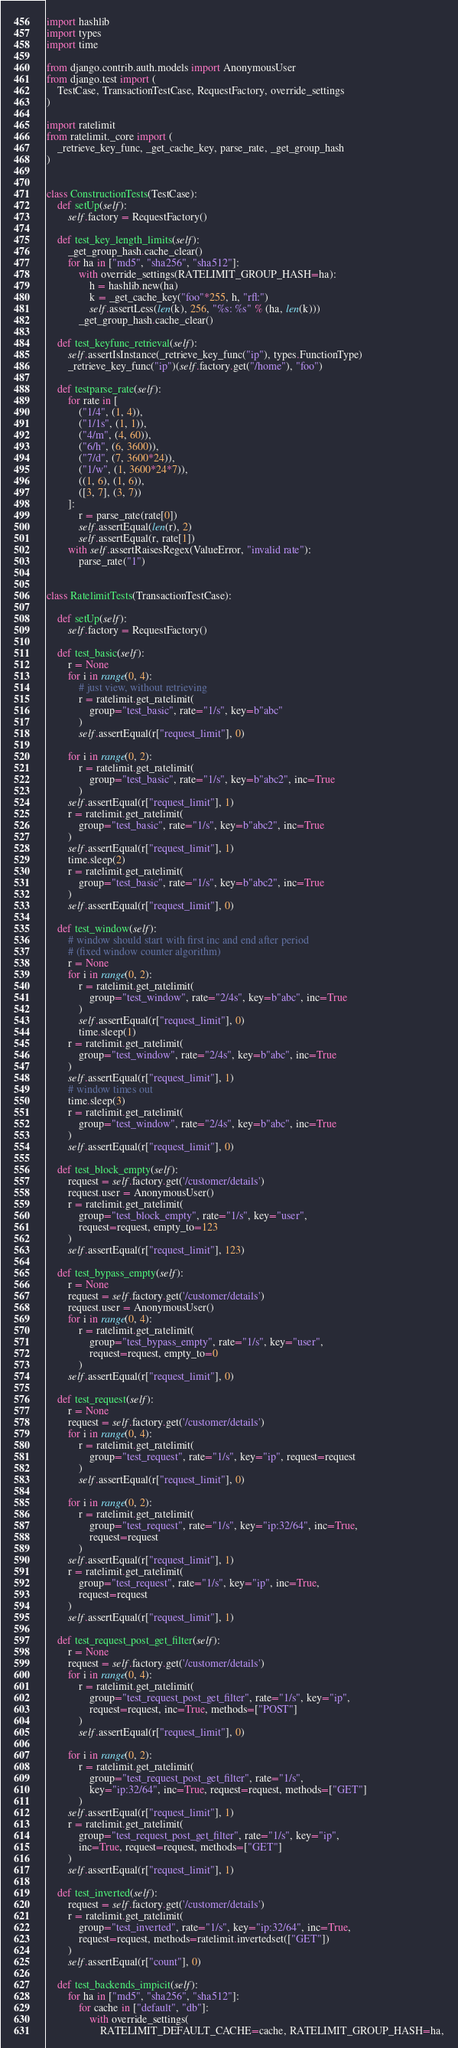Convert code to text. <code><loc_0><loc_0><loc_500><loc_500><_Python_>
import hashlib
import types
import time

from django.contrib.auth.models import AnonymousUser
from django.test import (
    TestCase, TransactionTestCase, RequestFactory, override_settings
)

import ratelimit
from ratelimit._core import (
    _retrieve_key_func, _get_cache_key, parse_rate, _get_group_hash
)


class ConstructionTests(TestCase):
    def setUp(self):
        self.factory = RequestFactory()

    def test_key_length_limits(self):
        _get_group_hash.cache_clear()
        for ha in ["md5", "sha256", "sha512"]:
            with override_settings(RATELIMIT_GROUP_HASH=ha):
                h = hashlib.new(ha)
                k = _get_cache_key("foo"*255, h, "rfl:")
                self.assertLess(len(k), 256, "%s: %s" % (ha, len(k)))
            _get_group_hash.cache_clear()

    def test_keyfunc_retrieval(self):
        self.assertIsInstance(_retrieve_key_func("ip"), types.FunctionType)
        _retrieve_key_func("ip")(self.factory.get("/home"), "foo")

    def testparse_rate(self):
        for rate in [
            ("1/4", (1, 4)),
            ("1/1s", (1, 1)),
            ("4/m", (4, 60)),
            ("6/h", (6, 3600)),
            ("7/d", (7, 3600*24)),
            ("1/w", (1, 3600*24*7)),
            ((1, 6), (1, 6)),
            ([3, 7], (3, 7))
        ]:
            r = parse_rate(rate[0])
            self.assertEqual(len(r), 2)
            self.assertEqual(r, rate[1])
        with self.assertRaisesRegex(ValueError, "invalid rate"):
            parse_rate("1")


class RatelimitTests(TransactionTestCase):

    def setUp(self):
        self.factory = RequestFactory()

    def test_basic(self):
        r = None
        for i in range(0, 4):
            # just view, without retrieving
            r = ratelimit.get_ratelimit(
                group="test_basic", rate="1/s", key=b"abc"
            )
            self.assertEqual(r["request_limit"], 0)

        for i in range(0, 2):
            r = ratelimit.get_ratelimit(
                group="test_basic", rate="1/s", key=b"abc2", inc=True
            )
        self.assertEqual(r["request_limit"], 1)
        r = ratelimit.get_ratelimit(
            group="test_basic", rate="1/s", key=b"abc2", inc=True
        )
        self.assertEqual(r["request_limit"], 1)
        time.sleep(2)
        r = ratelimit.get_ratelimit(
            group="test_basic", rate="1/s", key=b"abc2", inc=True
        )
        self.assertEqual(r["request_limit"], 0)

    def test_window(self):
        # window should start with first inc and end after period
        # (fixed window counter algorithm)
        r = None
        for i in range(0, 2):
            r = ratelimit.get_ratelimit(
                group="test_window", rate="2/4s", key=b"abc", inc=True
            )
            self.assertEqual(r["request_limit"], 0)
            time.sleep(1)
        r = ratelimit.get_ratelimit(
            group="test_window", rate="2/4s", key=b"abc", inc=True
        )
        self.assertEqual(r["request_limit"], 1)
        # window times out
        time.sleep(3)
        r = ratelimit.get_ratelimit(
            group="test_window", rate="2/4s", key=b"abc", inc=True
        )
        self.assertEqual(r["request_limit"], 0)

    def test_block_empty(self):
        request = self.factory.get('/customer/details')
        request.user = AnonymousUser()
        r = ratelimit.get_ratelimit(
            group="test_block_empty", rate="1/s", key="user",
            request=request, empty_to=123
        )
        self.assertEqual(r["request_limit"], 123)

    def test_bypass_empty(self):
        r = None
        request = self.factory.get('/customer/details')
        request.user = AnonymousUser()
        for i in range(0, 4):
            r = ratelimit.get_ratelimit(
                group="test_bypass_empty", rate="1/s", key="user",
                request=request, empty_to=0
            )
        self.assertEqual(r["request_limit"], 0)

    def test_request(self):
        r = None
        request = self.factory.get('/customer/details')
        for i in range(0, 4):
            r = ratelimit.get_ratelimit(
                group="test_request", rate="1/s", key="ip", request=request
            )
            self.assertEqual(r["request_limit"], 0)

        for i in range(0, 2):
            r = ratelimit.get_ratelimit(
                group="test_request", rate="1/s", key="ip:32/64", inc=True,
                request=request
            )
        self.assertEqual(r["request_limit"], 1)
        r = ratelimit.get_ratelimit(
            group="test_request", rate="1/s", key="ip", inc=True,
            request=request
        )
        self.assertEqual(r["request_limit"], 1)

    def test_request_post_get_filter(self):
        r = None
        request = self.factory.get('/customer/details')
        for i in range(0, 4):
            r = ratelimit.get_ratelimit(
                group="test_request_post_get_filter", rate="1/s", key="ip",
                request=request, inc=True, methods=["POST"]
            )
            self.assertEqual(r["request_limit"], 0)

        for i in range(0, 2):
            r = ratelimit.get_ratelimit(
                group="test_request_post_get_filter", rate="1/s",
                key="ip:32/64", inc=True, request=request, methods=["GET"]
            )
        self.assertEqual(r["request_limit"], 1)
        r = ratelimit.get_ratelimit(
            group="test_request_post_get_filter", rate="1/s", key="ip",
            inc=True, request=request, methods=["GET"]
        )
        self.assertEqual(r["request_limit"], 1)

    def test_inverted(self):
        request = self.factory.get('/customer/details')
        r = ratelimit.get_ratelimit(
            group="test_inverted", rate="1/s", key="ip:32/64", inc=True,
            request=request, methods=ratelimit.invertedset(["GET"])
        )
        self.assertEqual(r["count"], 0)

    def test_backends_impicit(self):
        for ha in ["md5", "sha256", "sha512"]:
            for cache in ["default", "db"]:
                with override_settings(
                    RATELIMIT_DEFAULT_CACHE=cache, RATELIMIT_GROUP_HASH=ha,</code> 